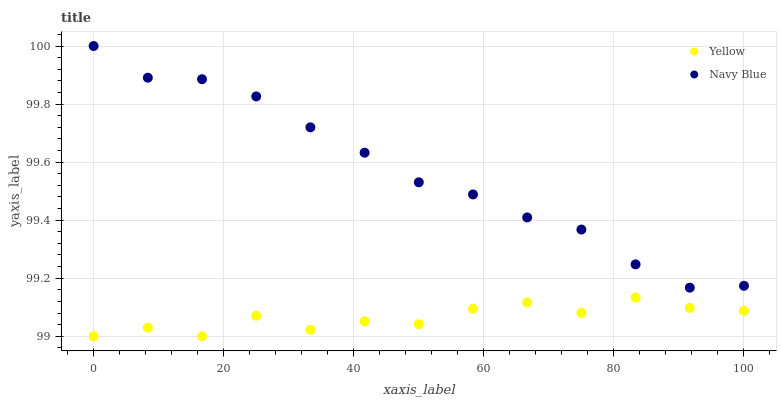Does Yellow have the minimum area under the curve?
Answer yes or no. Yes. Does Navy Blue have the maximum area under the curve?
Answer yes or no. Yes. Does Yellow have the maximum area under the curve?
Answer yes or no. No. Is Navy Blue the smoothest?
Answer yes or no. Yes. Is Yellow the roughest?
Answer yes or no. Yes. Is Yellow the smoothest?
Answer yes or no. No. Does Yellow have the lowest value?
Answer yes or no. Yes. Does Navy Blue have the highest value?
Answer yes or no. Yes. Does Yellow have the highest value?
Answer yes or no. No. Is Yellow less than Navy Blue?
Answer yes or no. Yes. Is Navy Blue greater than Yellow?
Answer yes or no. Yes. Does Yellow intersect Navy Blue?
Answer yes or no. No. 